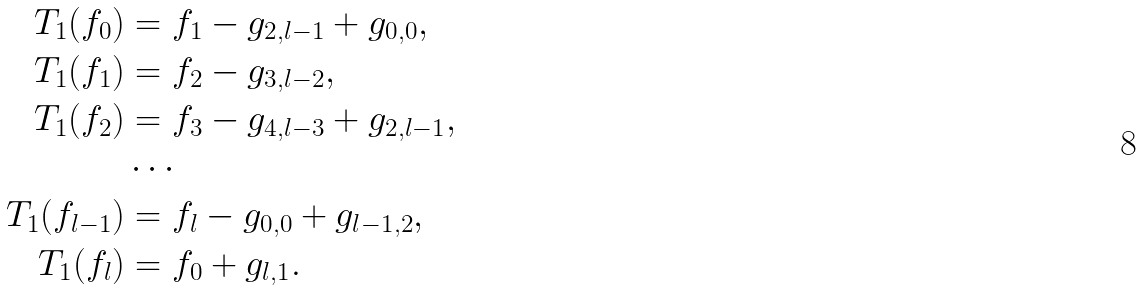Convert formula to latex. <formula><loc_0><loc_0><loc_500><loc_500>T _ { 1 } ( f _ { 0 } ) & = f _ { 1 } - g _ { 2 , l - 1 } + g _ { 0 , 0 } , \\ T _ { 1 } ( f _ { 1 } ) & = f _ { 2 } - g _ { 3 , l - 2 } , \\ T _ { 1 } ( f _ { 2 } ) & = f _ { 3 } - g _ { 4 , l - 3 } + g _ { 2 , l - 1 } , \\ & \cdots \\ T _ { 1 } ( f _ { l - 1 } ) & = f _ { l } - g _ { 0 , 0 } + g _ { l - 1 , 2 } , \\ T _ { 1 } ( f _ { l } ) & = f _ { 0 } + g _ { l , 1 } .</formula> 